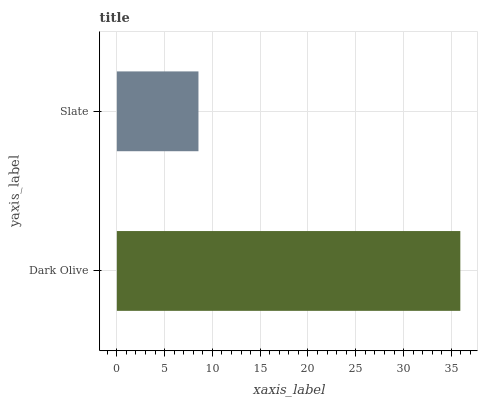Is Slate the minimum?
Answer yes or no. Yes. Is Dark Olive the maximum?
Answer yes or no. Yes. Is Slate the maximum?
Answer yes or no. No. Is Dark Olive greater than Slate?
Answer yes or no. Yes. Is Slate less than Dark Olive?
Answer yes or no. Yes. Is Slate greater than Dark Olive?
Answer yes or no. No. Is Dark Olive less than Slate?
Answer yes or no. No. Is Dark Olive the high median?
Answer yes or no. Yes. Is Slate the low median?
Answer yes or no. Yes. Is Slate the high median?
Answer yes or no. No. Is Dark Olive the low median?
Answer yes or no. No. 